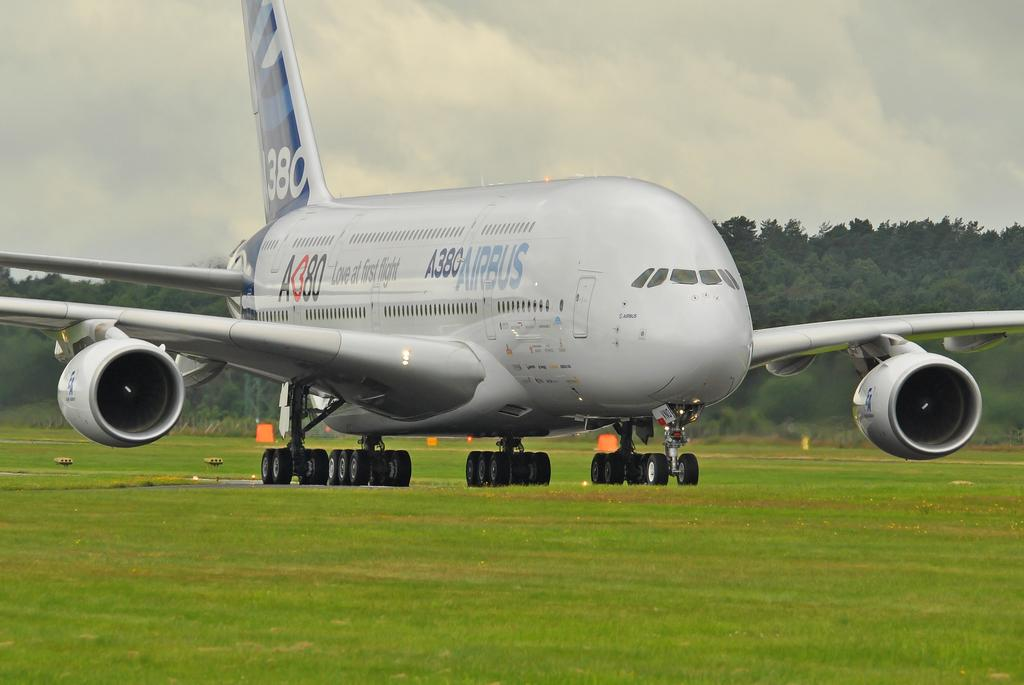What is the main subject of the image? The main subject of the image is an aeroplane. What is the color of the aeroplane? The aeroplane is white in color. What feature can be seen on the aeroplane? The aeroplane has wheels. What type of natural vegetation is visible in the image? There are trees visible in the image. What type of man-made structures are visible in the image? There are boards visible in the image. What is the color of the sky in the image? The sky is white in color. Can you hear the whistle of the boy in the image? There is no boy or whistle present in the image. What type of motion is the aeroplane performing in the image? The image does not show the aeroplane in motion; it is stationary. 